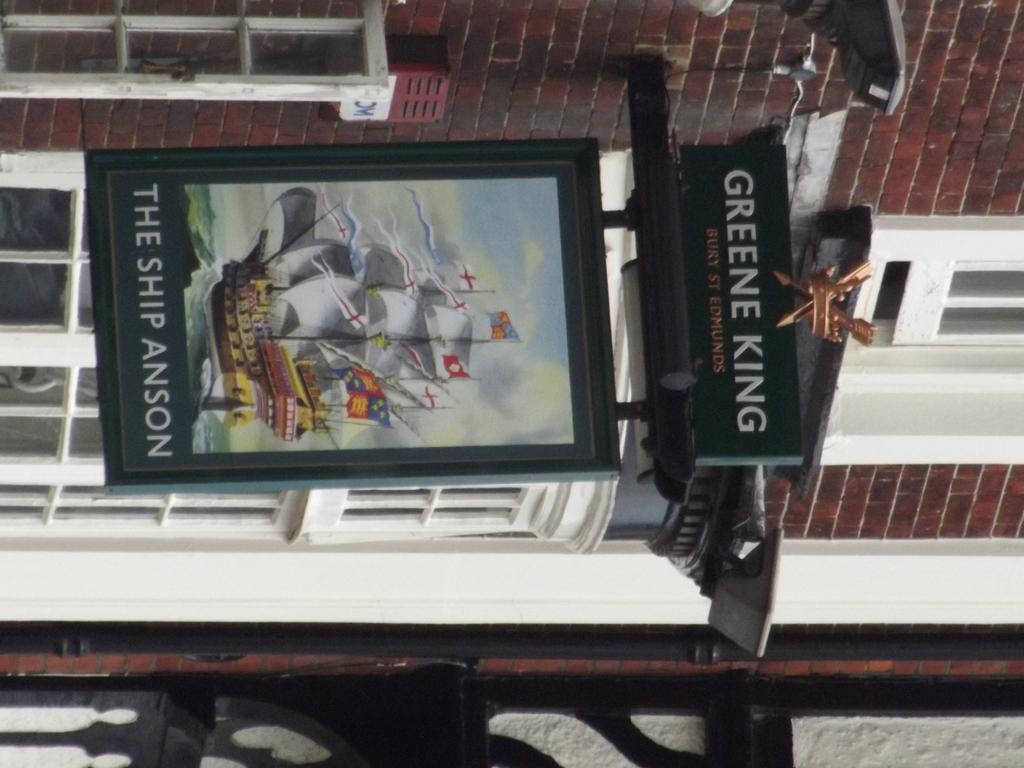What is written on this sign?
Give a very brief answer. The ship anson. What king is written on the sign?
Your answer should be compact. Greene. 